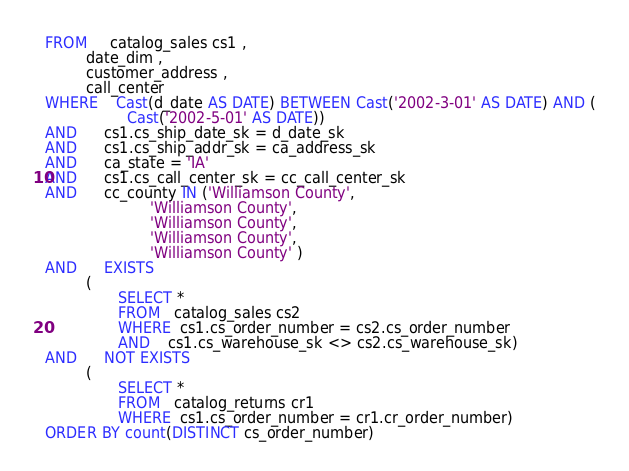<code> <loc_0><loc_0><loc_500><loc_500><_SQL_>FROM     catalog_sales cs1 ,
         date_dim ,
         customer_address ,
         call_center
WHERE    Cast(d_date AS DATE) BETWEEN Cast('2002-3-01' AS DATE) AND (
                  Cast('2002-5-01' AS DATE))
AND      cs1.cs_ship_date_sk = d_date_sk
AND      cs1.cs_ship_addr_sk = ca_address_sk
AND      ca_state = 'IA'
AND      cs1.cs_call_center_sk = cc_call_center_sk
AND      cc_county IN ('Williamson County',
                       'Williamson County',
                       'Williamson County',
                       'Williamson County',
                       'Williamson County' )
AND      EXISTS
         (
                SELECT *
                FROM   catalog_sales cs2
                WHERE  cs1.cs_order_number = cs2.cs_order_number
                AND    cs1.cs_warehouse_sk <> cs2.cs_warehouse_sk)
AND      NOT EXISTS
         (
                SELECT *
                FROM   catalog_returns cr1
                WHERE  cs1.cs_order_number = cr1.cr_order_number)
ORDER BY count(DISTINCT cs_order_number)
</code> 